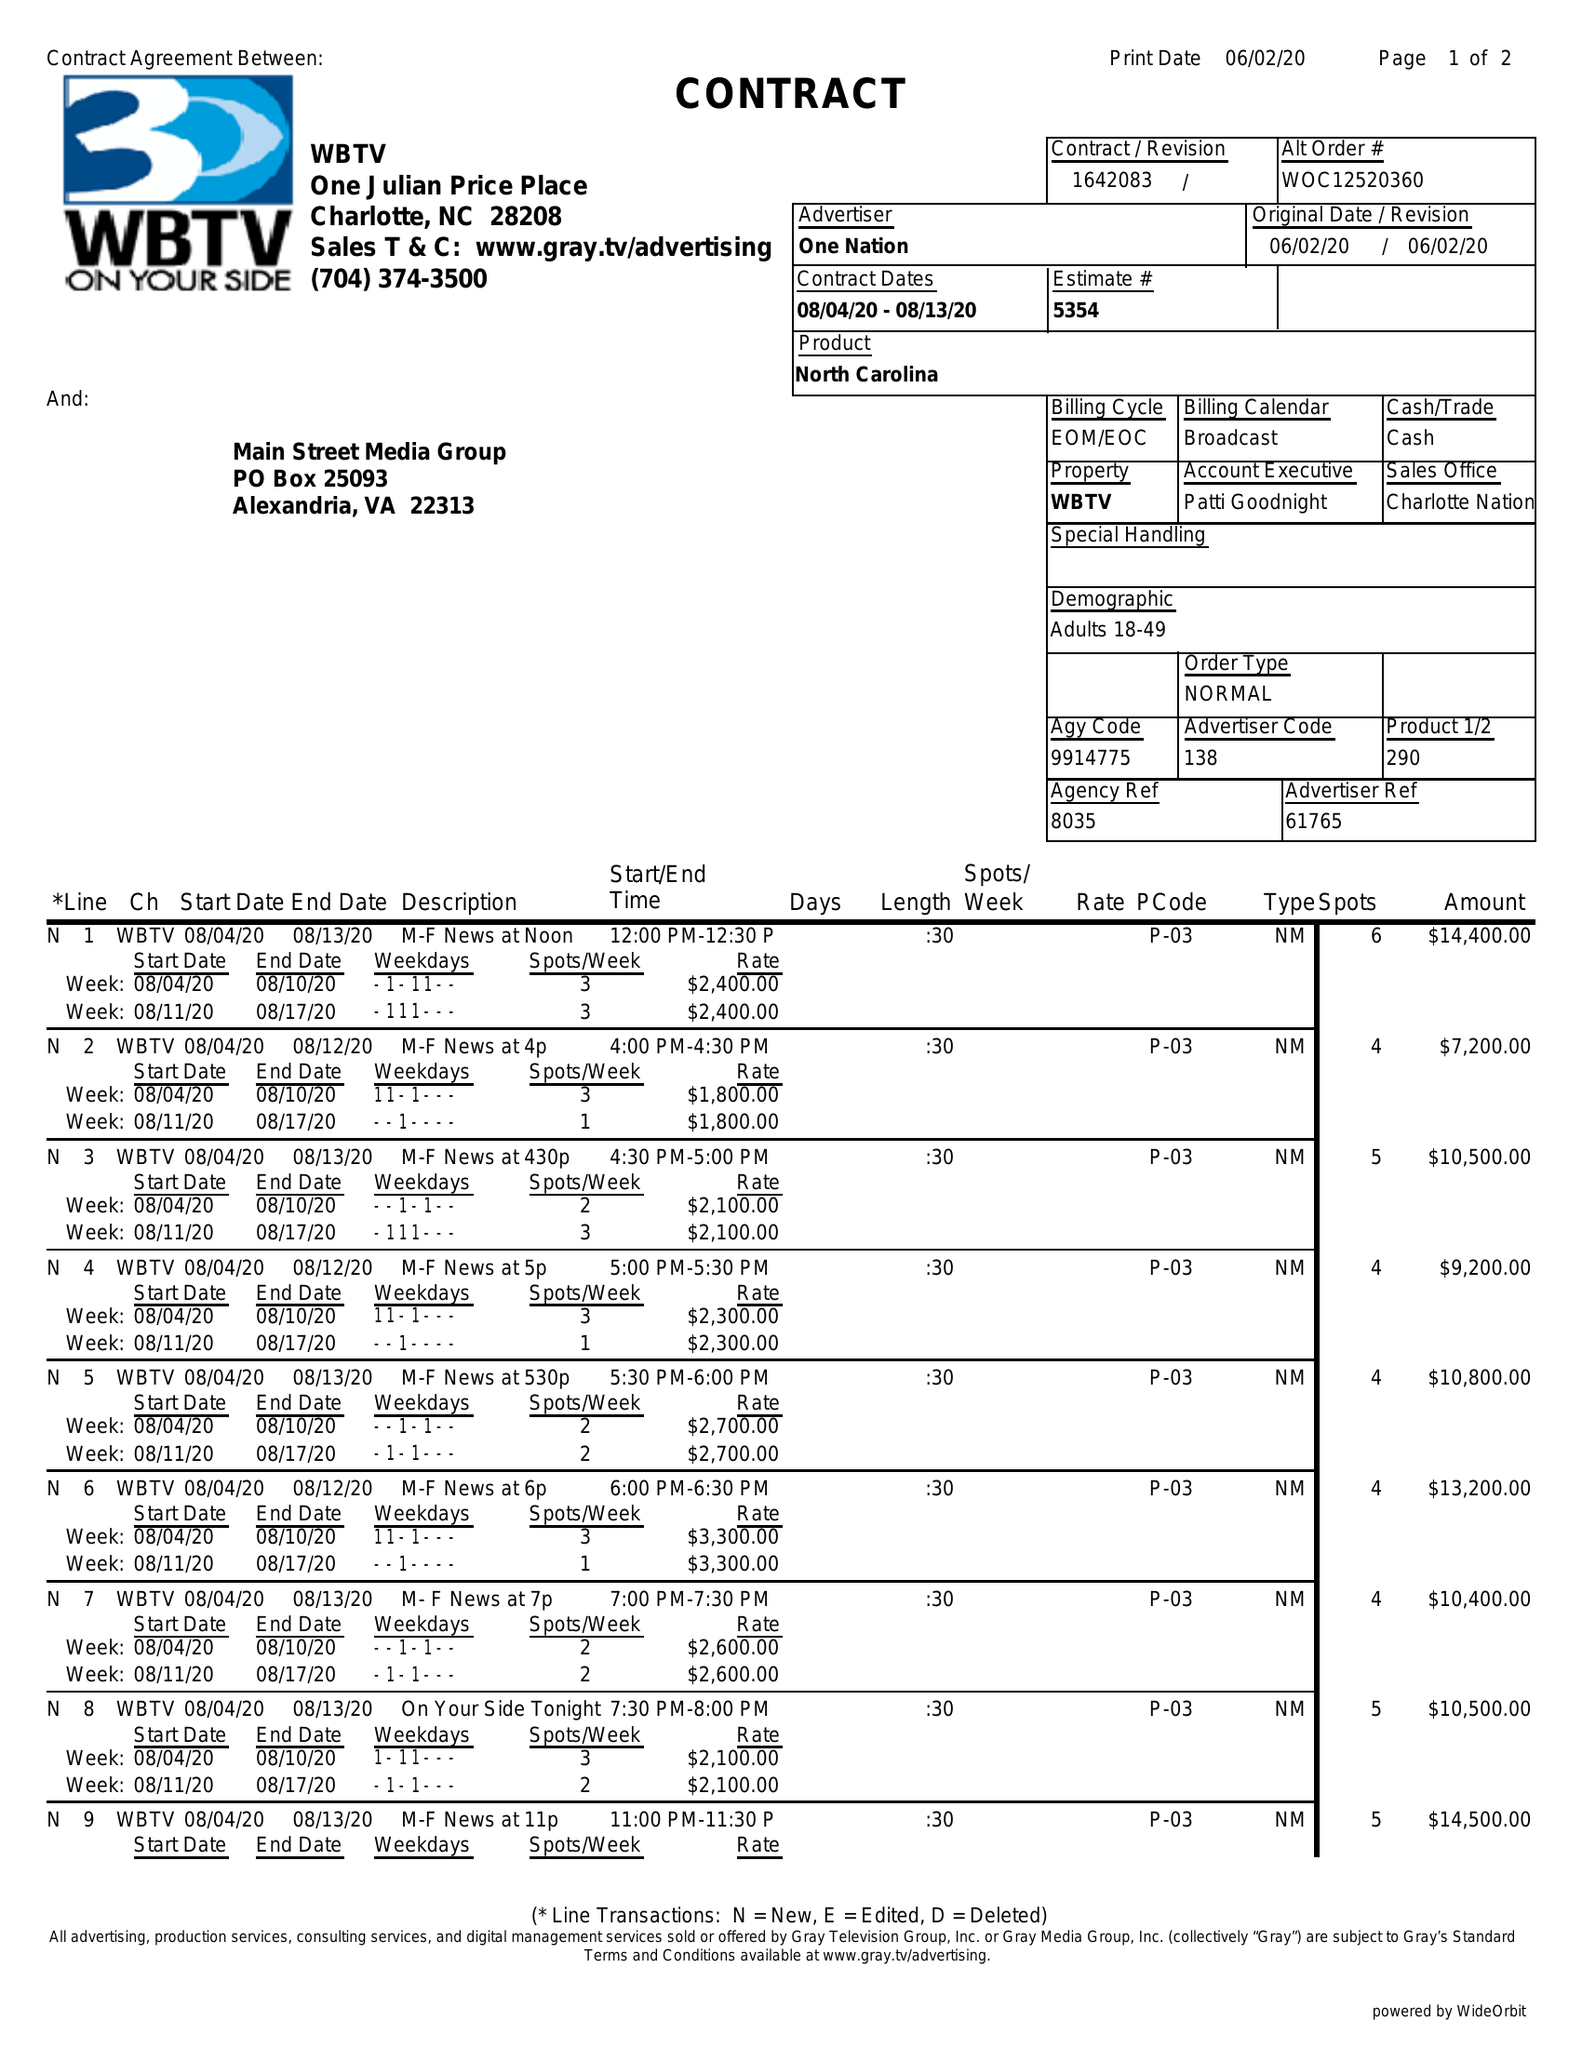What is the value for the flight_from?
Answer the question using a single word or phrase. 08/04/20 